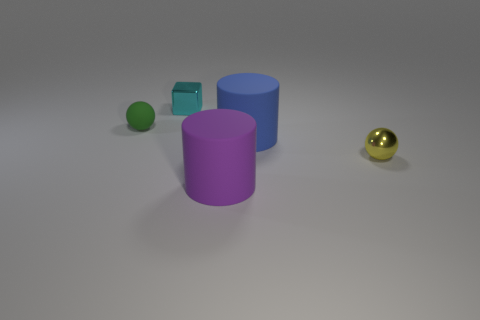Add 3 large purple cylinders. How many objects exist? 8 Subtract all cylinders. How many objects are left? 3 Subtract 1 purple cylinders. How many objects are left? 4 Subtract all blue cylinders. Subtract all cyan things. How many objects are left? 3 Add 1 yellow objects. How many yellow objects are left? 2 Add 2 small green objects. How many small green objects exist? 3 